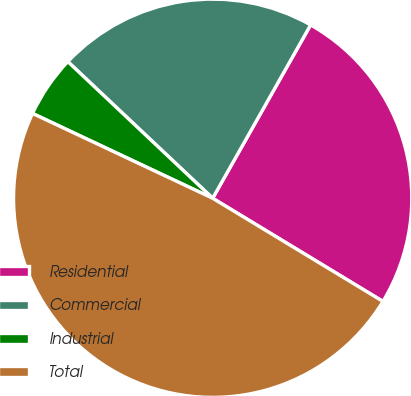<chart> <loc_0><loc_0><loc_500><loc_500><pie_chart><fcel>Residential<fcel>Commercial<fcel>Industrial<fcel>Total<nl><fcel>25.48%<fcel>21.15%<fcel>5.03%<fcel>48.33%<nl></chart> 